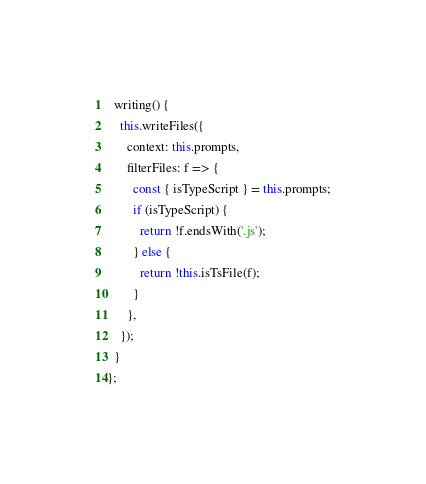<code> <loc_0><loc_0><loc_500><loc_500><_JavaScript_>
  writing() {
    this.writeFiles({
      context: this.prompts,
      filterFiles: f => {
        const { isTypeScript } = this.prompts;
        if (isTypeScript) {
          return !f.endsWith('.js');
        } else {
          return !this.isTsFile(f);
        }
      },
    });
  }
};
</code> 